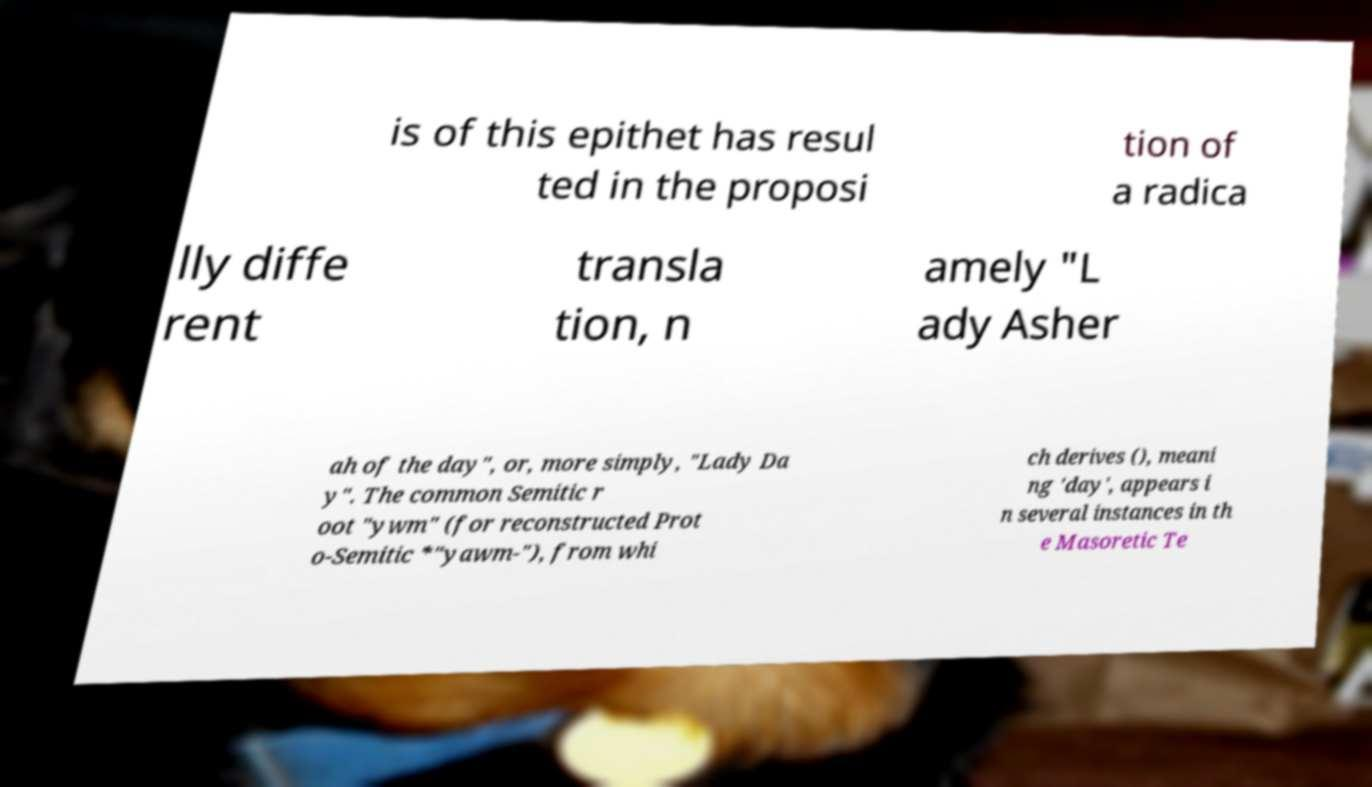Can you accurately transcribe the text from the provided image for me? is of this epithet has resul ted in the proposi tion of a radica lly diffe rent transla tion, n amely "L ady Asher ah of the day", or, more simply, "Lady Da y". The common Semitic r oot "ywm" (for reconstructed Prot o-Semitic *"yawm-"), from whi ch derives (), meani ng 'day', appears i n several instances in th e Masoretic Te 